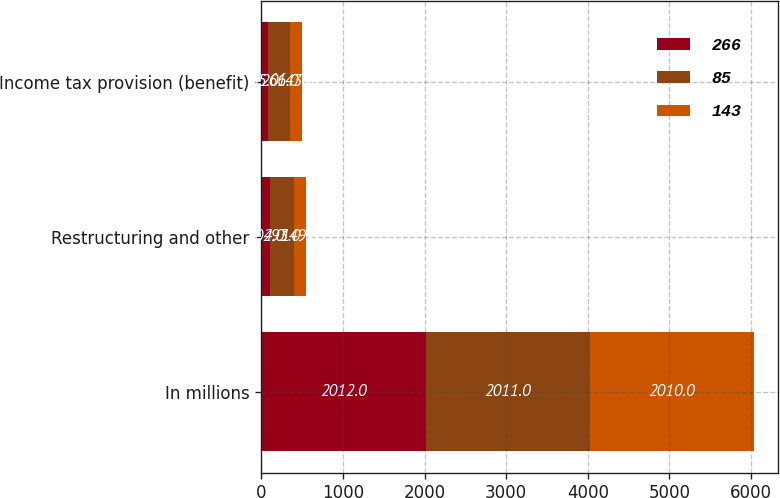Convert chart to OTSL. <chart><loc_0><loc_0><loc_500><loc_500><stacked_bar_chart><ecel><fcel>In millions<fcel>Restructuring and other<fcel>Income tax provision (benefit)<nl><fcel>266<fcel>2012<fcel>104<fcel>85<nl><fcel>85<fcel>2011<fcel>293<fcel>266<nl><fcel>143<fcel>2010<fcel>149<fcel>143<nl></chart> 